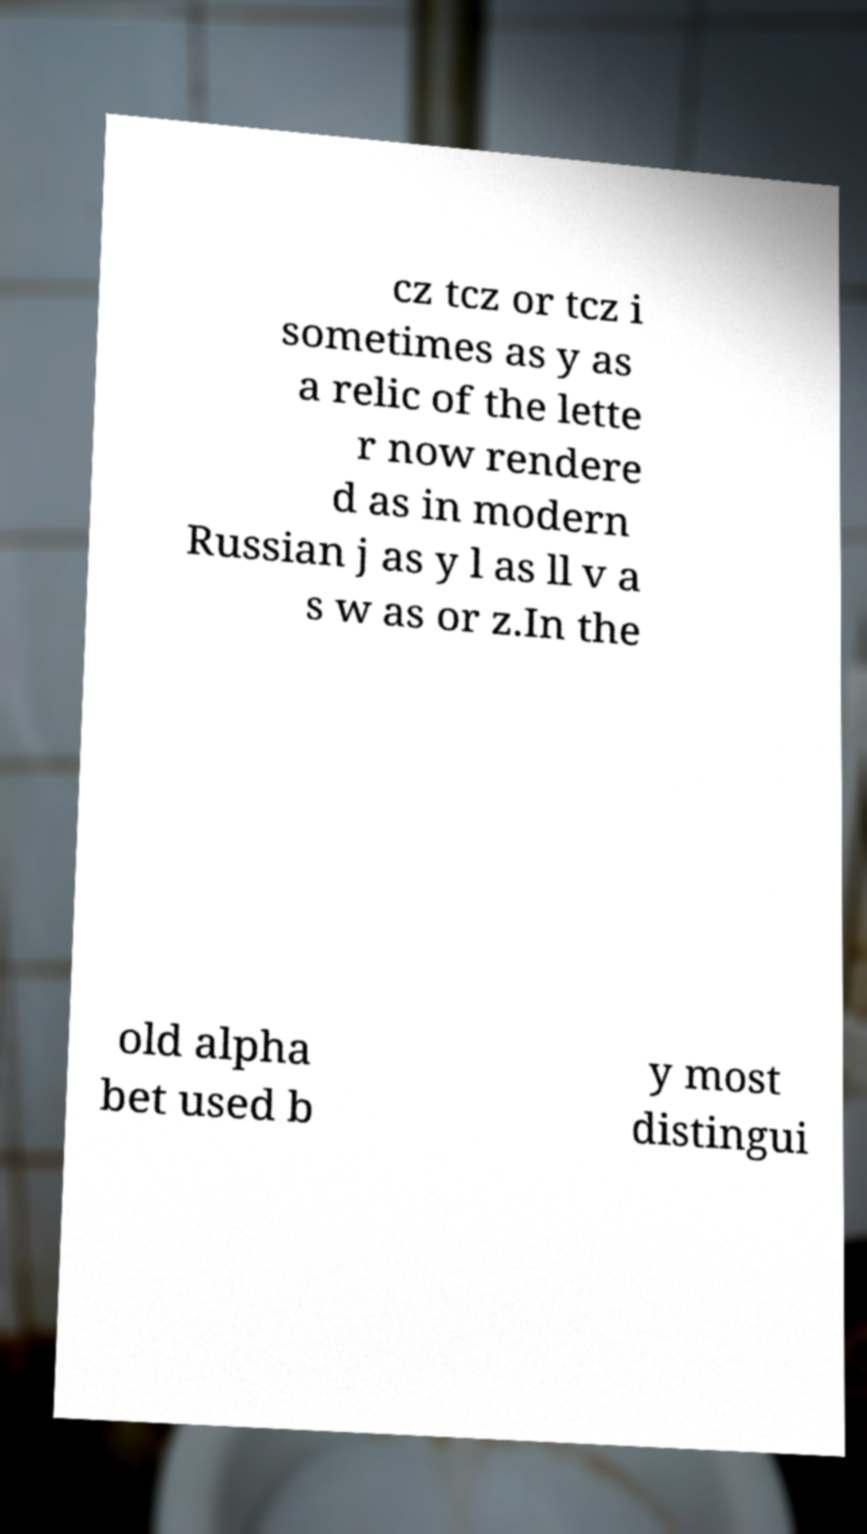What messages or text are displayed in this image? I need them in a readable, typed format. cz tcz or tcz i sometimes as y as a relic of the lette r now rendere d as in modern Russian j as y l as ll v a s w as or z.In the old alpha bet used b y most distingui 